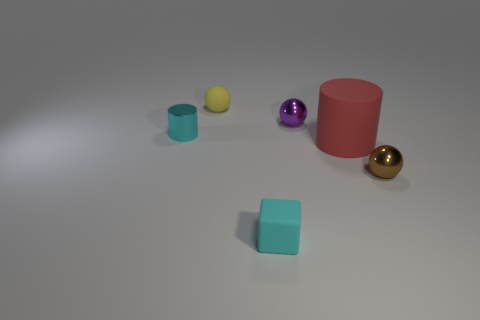Subtract all tiny purple spheres. How many spheres are left? 2 Add 1 rubber objects. How many objects exist? 7 Subtract all cyan cylinders. How many cylinders are left? 1 Subtract all cubes. How many objects are left? 5 Subtract 1 yellow balls. How many objects are left? 5 Subtract all blue cylinders. Subtract all cyan balls. How many cylinders are left? 2 Subtract all tiny cylinders. Subtract all red objects. How many objects are left? 4 Add 4 shiny balls. How many shiny balls are left? 6 Add 1 spheres. How many spheres exist? 4 